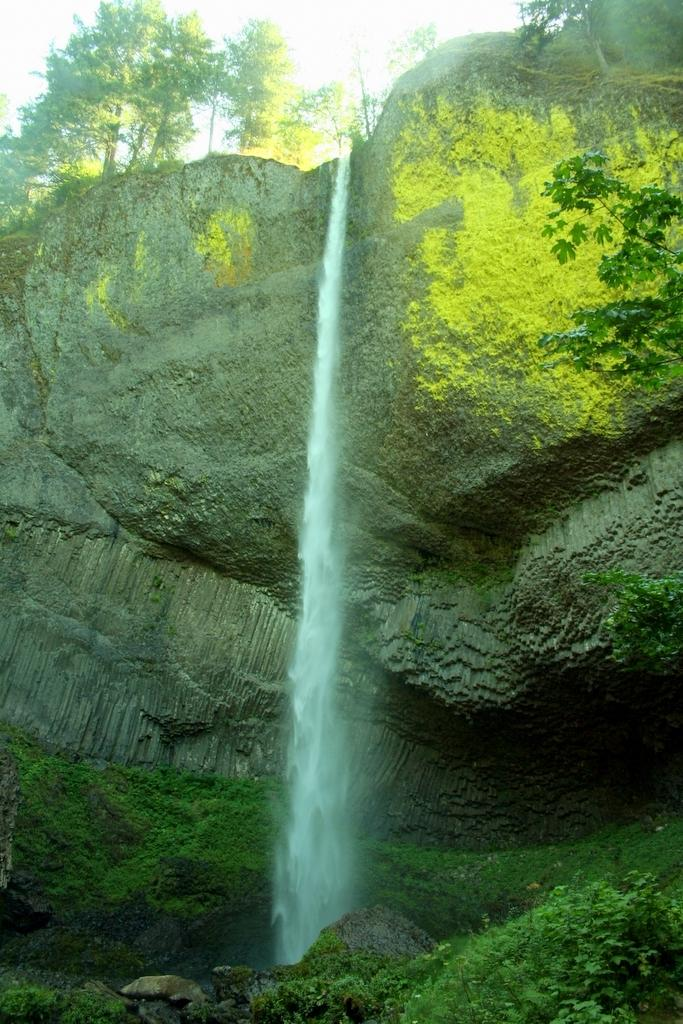What is the main subject in the middle of the image? There is a rock and a waterfall in the middle of the image. What type of vegetation can be seen at the bottom of the image? There are plants at the bottom of the image. What type of vegetation can be seen at the top of the image? There are trees at the top of the image. What type of doctor can be seen examining the rock in the image? There is no doctor present in the image; it features a rock and a waterfall surrounded by plants and trees. 